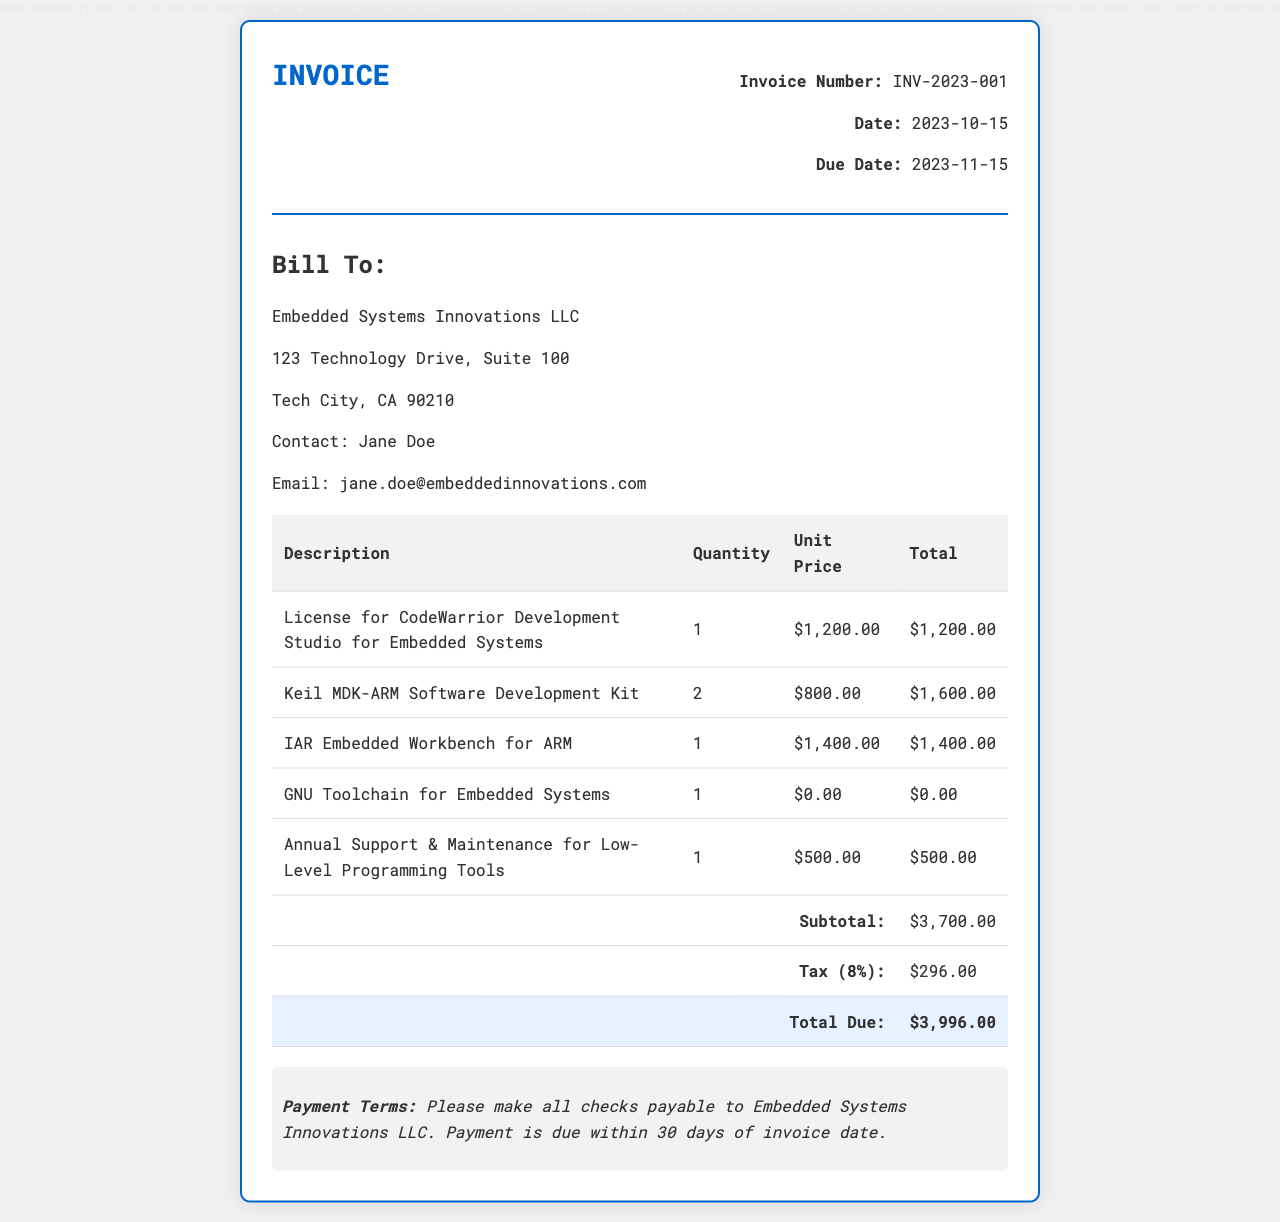What is the invoice number? The invoice number is listed in the document's details section, which is INV-2023-001.
Answer: INV-2023-001 What is the date of the invoice? The date of the invoice is specified as the day it was issued, which is 2023-10-15.
Answer: 2023-10-15 What is the total due amount? The total due amount is summarized at the bottom of the table as $3,996.00.
Answer: $3,996.00 How many Keil MDK-ARM Software Development Kits were sold? The quantity of Keil MDK-ARM Software Development Kits listed in the invoice is mentioned as 2.
Answer: 2 What is the unit price of the IAR Embedded Workbench for ARM? The unit price for the IAR Embedded Workbench for ARM is detailed in the table as $1,400.00.
Answer: $1,400.00 What is the subtotal of the invoice? The subtotal, before tax, is calculated and presented as $3,700.00 in the invoice.
Answer: $3,700.00 What percentage is the tax stated in the invoice? The tax rate mentioned in the invoice is calculated as 8%.
Answer: 8% Who is the contact person for the billing address? The contact person listed under the billing address is Jane Doe.
Answer: Jane Doe What is the payment term stated in the invoice? The document specifies that payment is due within 30 days of the invoice date.
Answer: 30 days 